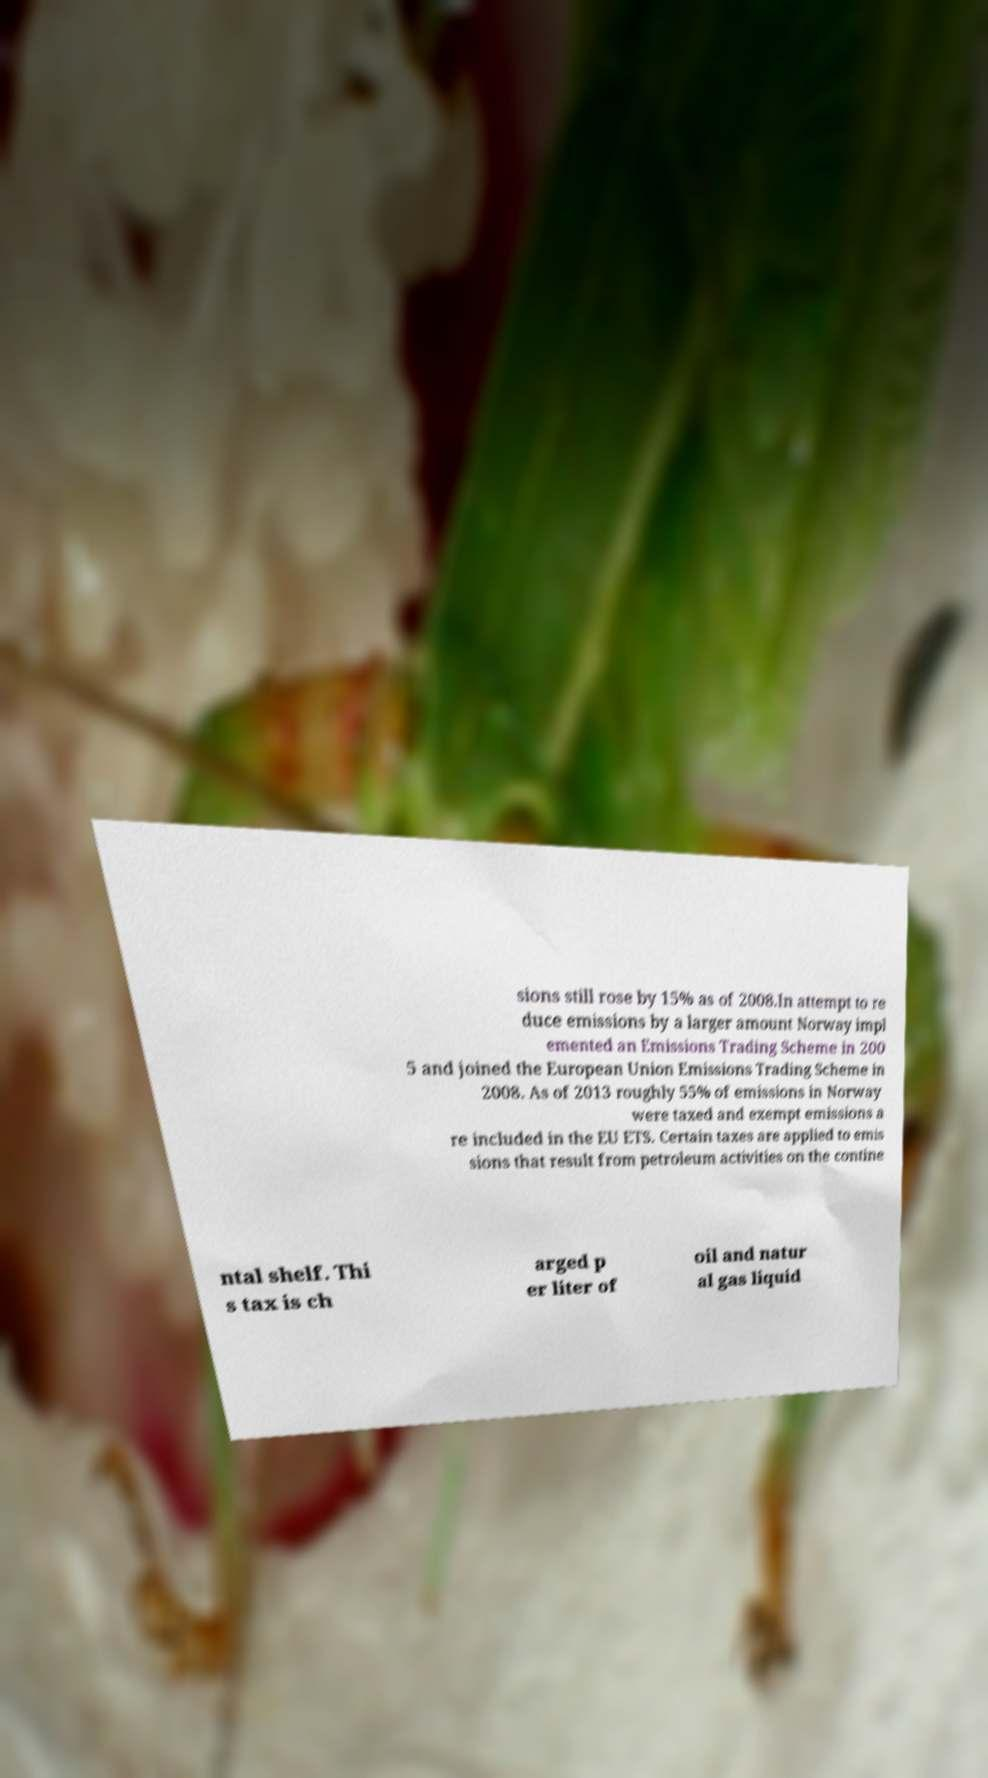What messages or text are displayed in this image? I need them in a readable, typed format. sions still rose by 15% as of 2008.In attempt to re duce emissions by a larger amount Norway impl emented an Emissions Trading Scheme in 200 5 and joined the European Union Emissions Trading Scheme in 2008. As of 2013 roughly 55% of emissions in Norway were taxed and exempt emissions a re included in the EU ETS. Certain taxes are applied to emis sions that result from petroleum activities on the contine ntal shelf. Thi s tax is ch arged p er liter of oil and natur al gas liquid 